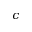<formula> <loc_0><loc_0><loc_500><loc_500>c</formula> 